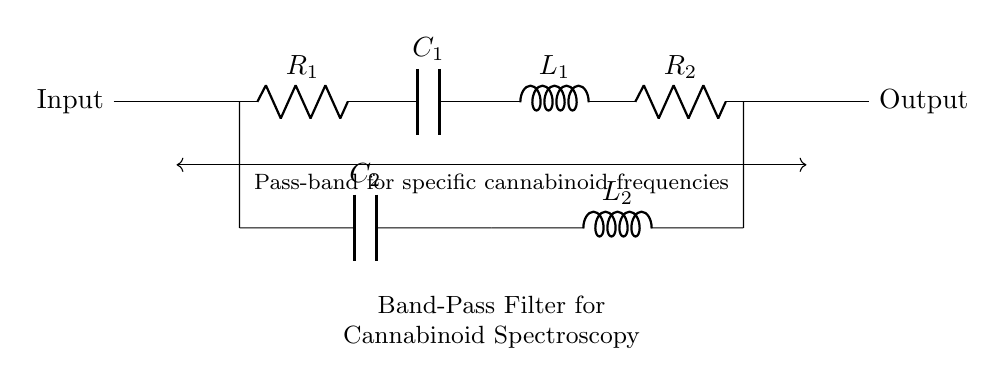What type of filter is represented in this circuit? The circuit diagram depicts a band-pass filter, as indicated by the label within the diagram. Band-pass filters allow frequencies within a certain range to pass through while attenuating frequencies outside that range.
Answer: Band-pass filter What components are used in the circuit? The circuit consists of resistors, capacitors, and inductors. Specifically, there are two resistors (R1 and R2), two capacitors (C1 and C2), and two inductors (L1 and L2).
Answer: Resistors, capacitors, inductors What is the role of capacitors in this band-pass filter? Capacitors in a band-pass filter help determine the cutoff frequencies of the filter by allowing certain frequency signals to pass while blocking others. In this case, C1 and C2 work in conjunction with R and L components to form the filter characteristics.
Answer: Determine cutoff frequencies What can you say about the connection between C2 and the subsequent L2 in the circuit? C2 and L2 are connected in series, allowing the voltage across C2 to influence L2, which is crucial for filtering specific frequencies. This combination effectively helps in selecting the desired frequency band for vibration analysis in cannabinoids.
Answer: Series connection How does this circuit isolate specific cannabinoid frequencies? The combination of R, C, and L components creates resonance at certain frequencies, allowing those frequencies (specific to cannabinoids) to pass through while rejecting others. The band-pass filter characteristics are crucial for spectral analysis in isolating these frequencies.
Answer: Resonance filtering What does the pass-band represent in this filter? The pass-band is the range of frequencies where the circuit allows signals to pass with minimal attenuation. This is typically defined by the resonant frequency created by the combination of the inductor and capacitor in the circuit.
Answer: Allowable frequency range 